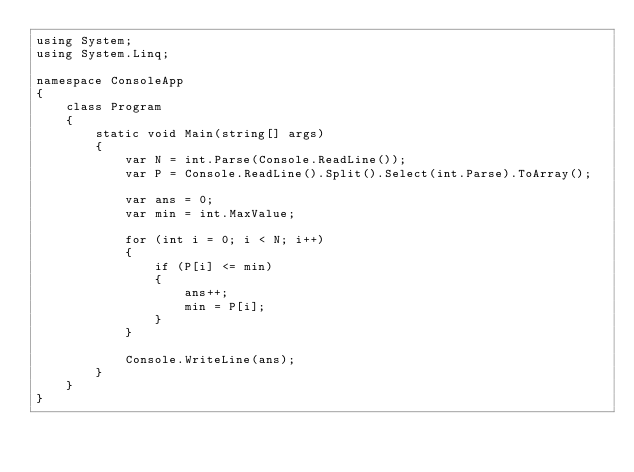<code> <loc_0><loc_0><loc_500><loc_500><_C#_>using System;
using System.Linq;

namespace ConsoleApp
{
    class Program
    {
        static void Main(string[] args)
        {
            var N = int.Parse(Console.ReadLine());
            var P = Console.ReadLine().Split().Select(int.Parse).ToArray();

            var ans = 0;
            var min = int.MaxValue;

            for (int i = 0; i < N; i++)
            {
                if (P[i] <= min)
                {
                    ans++;
                    min = P[i];
                }
            }

            Console.WriteLine(ans);
        }
    }
}</code> 